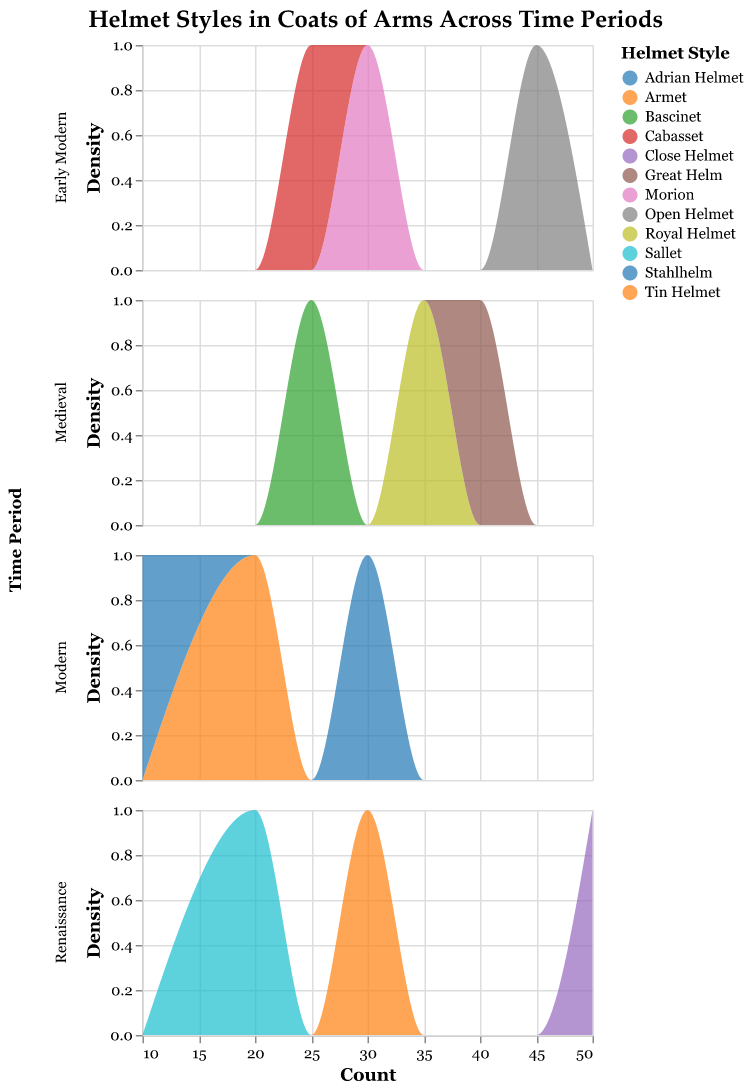What is the total number of helmets depicted for the Medieval period? To find this, sum up the counts for all helmet styles in the Medieval period. Add 35 (Royal Helmet) + 25 (Bascinet) + 40 (Great Helm).
Answer: 100 Which time period has the highest count for a single helmet style? Compare the maximum count for each time period: Medieval (Great Helm: 40), Renaissance (Close Helmet: 50), Early Modern (Open Helmet: 45), Modern (Stahlhelm: 30). The highest count is 50 in the Renaissance period.
Answer: Renaissance What is the sum of all helmet counts in the Renaissance period? Sum the counts for all helmet styles in the Renaissance period. Add 30 (Armet) + 20 (Sallet) + 50 (Close Helmet).
Answer: 100 Which helmet style appears most frequently in the Early Modern period? Compare the counts of each helmet style in the Early Modern period: Open Helmet (45), Morion (30), Cabasset (25). The highest count is 45 for Open Helmet.
Answer: Open Helmet How many different helmet styles are depicted across all time periods? Count the unique helmet styles listed in the data: Royal Helmet, Bascinet, Great Helm, Armet, Sallet, Close Helmet, Open Helmet, Morion, Cabasset, Tin Helmet, Adrian Helmet, Stahlhelm.
Answer: 11 What is the average number of helmets depicted per style in the Modern period? Sum the counts of all helmet styles in the Modern period and divide by the number of styles. Sum 20 (Tin Helmet) + 10 (Adrian Helmet) + 30 (Stahlhelm) = 60. Divide by 3 styles.
Answer: 20 Which helmet style in the Medieval period has the highest count? Compare the counts of each helmet style in the Medieval period: Royal Helmet (35), Bascinet (25), Great Helm (40). The highest count is 40 for Great Helm.
Answer: Great Helm Between the Medieval and Early Modern periods, which has the higher total count of helmets? Sum the counts for each period: Medieval (35 + 25 + 40 = 100), Early Modern (45 + 30 + 25 = 100). Both periods have the same total count of 100.
Answer: Equal Which helmet style has the lowest count in the Renaissance period? Compare the counts for helmet styles in the Renaissance period: Armet (30), Sallet (20), Close Helmet (50). The lowest count is 20 for Sallet.
Answer: Sallet 